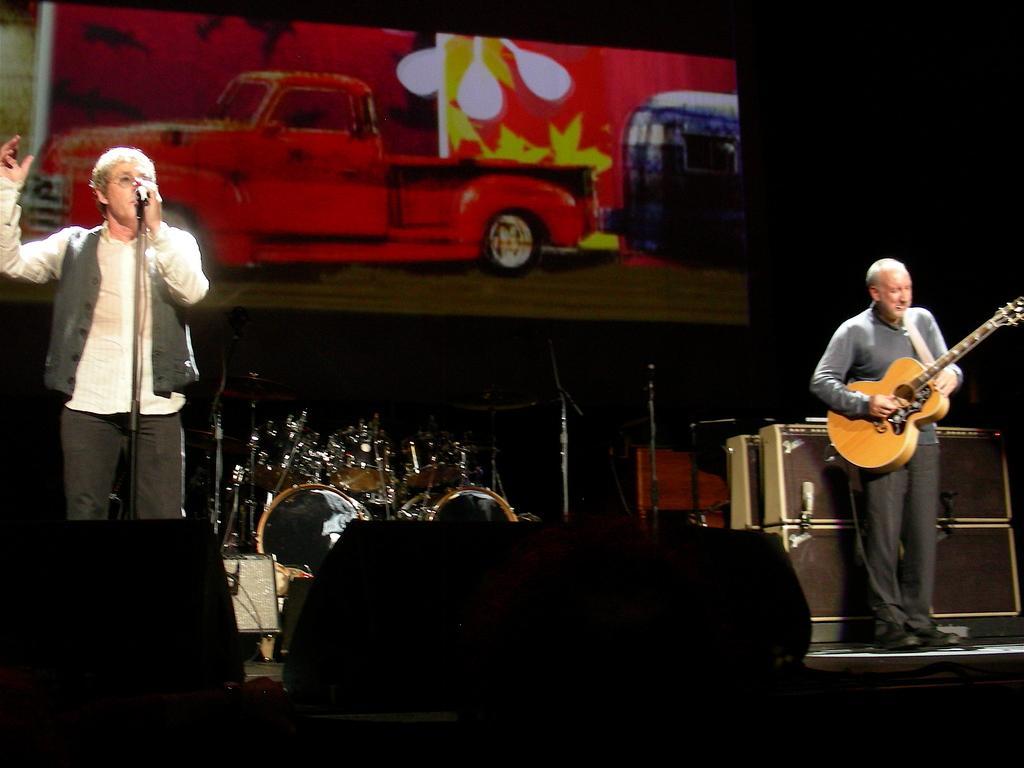Can you describe this image briefly? In this image I can see to man standing on the stage, the person on the right side is playing guitar and the person on the left side is singing song in front of a microphone. 